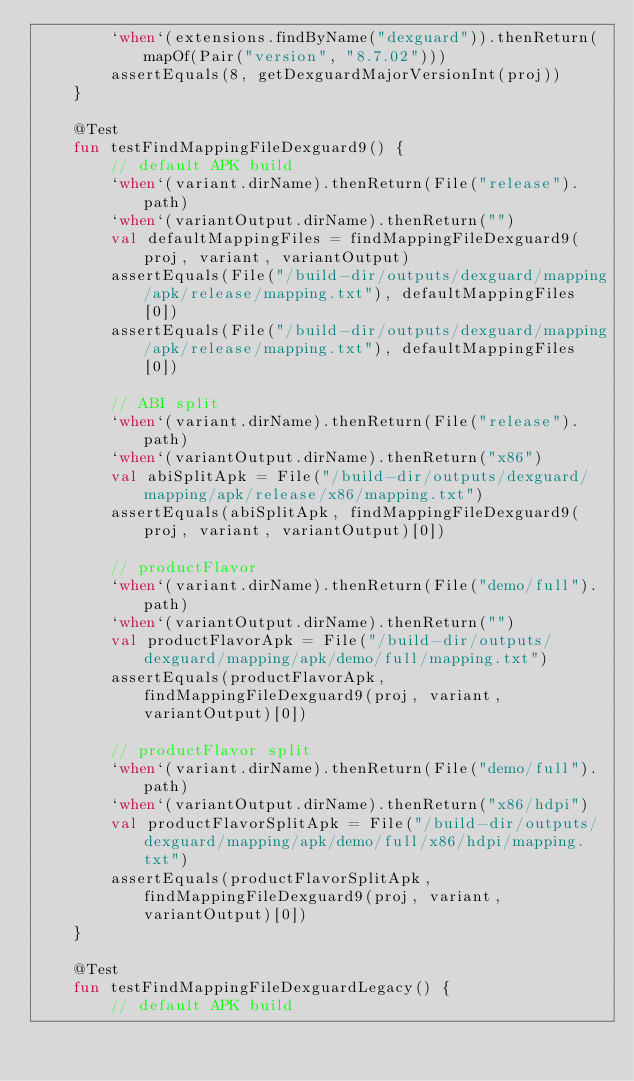<code> <loc_0><loc_0><loc_500><loc_500><_Kotlin_>        `when`(extensions.findByName("dexguard")).thenReturn(mapOf(Pair("version", "8.7.02")))
        assertEquals(8, getDexguardMajorVersionInt(proj))
    }

    @Test
    fun testFindMappingFileDexguard9() {
        // default APK build
        `when`(variant.dirName).thenReturn(File("release").path)
        `when`(variantOutput.dirName).thenReturn("")
        val defaultMappingFiles = findMappingFileDexguard9(proj, variant, variantOutput)
        assertEquals(File("/build-dir/outputs/dexguard/mapping/apk/release/mapping.txt"), defaultMappingFiles[0])
        assertEquals(File("/build-dir/outputs/dexguard/mapping/apk/release/mapping.txt"), defaultMappingFiles[0])

        // ABI split
        `when`(variant.dirName).thenReturn(File("release").path)
        `when`(variantOutput.dirName).thenReturn("x86")
        val abiSplitApk = File("/build-dir/outputs/dexguard/mapping/apk/release/x86/mapping.txt")
        assertEquals(abiSplitApk, findMappingFileDexguard9(proj, variant, variantOutput)[0])

        // productFlavor
        `when`(variant.dirName).thenReturn(File("demo/full").path)
        `when`(variantOutput.dirName).thenReturn("")
        val productFlavorApk = File("/build-dir/outputs/dexguard/mapping/apk/demo/full/mapping.txt")
        assertEquals(productFlavorApk, findMappingFileDexguard9(proj, variant, variantOutput)[0])

        // productFlavor split
        `when`(variant.dirName).thenReturn(File("demo/full").path)
        `when`(variantOutput.dirName).thenReturn("x86/hdpi")
        val productFlavorSplitApk = File("/build-dir/outputs/dexguard/mapping/apk/demo/full/x86/hdpi/mapping.txt")
        assertEquals(productFlavorSplitApk, findMappingFileDexguard9(proj, variant, variantOutput)[0])
    }

    @Test
    fun testFindMappingFileDexguardLegacy() {
        // default APK build</code> 